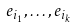Convert formula to latex. <formula><loc_0><loc_0><loc_500><loc_500>e _ { i _ { 1 } } , \dots , e _ { i _ { k } }</formula> 